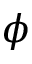Convert formula to latex. <formula><loc_0><loc_0><loc_500><loc_500>\phi</formula> 